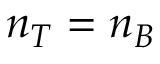Convert formula to latex. <formula><loc_0><loc_0><loc_500><loc_500>n _ { T } = n _ { B }</formula> 